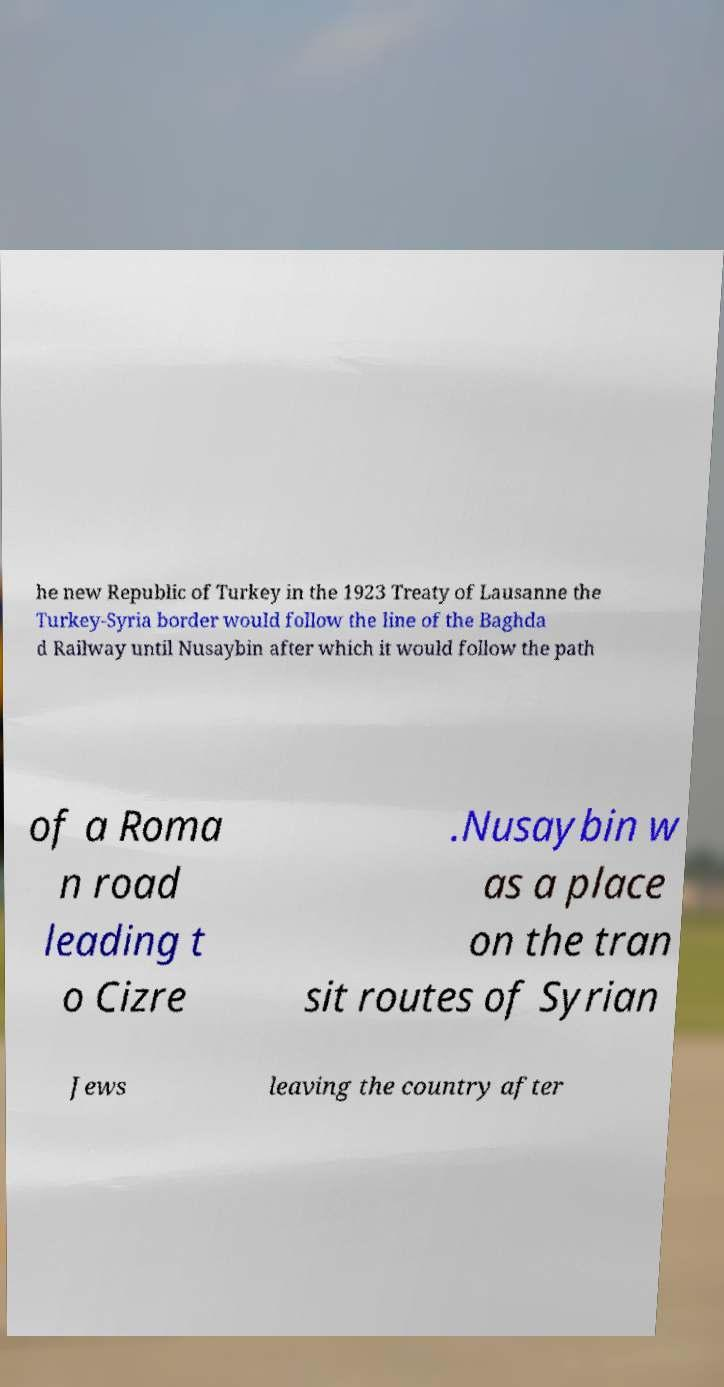There's text embedded in this image that I need extracted. Can you transcribe it verbatim? he new Republic of Turkey in the 1923 Treaty of Lausanne the Turkey-Syria border would follow the line of the Baghda d Railway until Nusaybin after which it would follow the path of a Roma n road leading t o Cizre .Nusaybin w as a place on the tran sit routes of Syrian Jews leaving the country after 